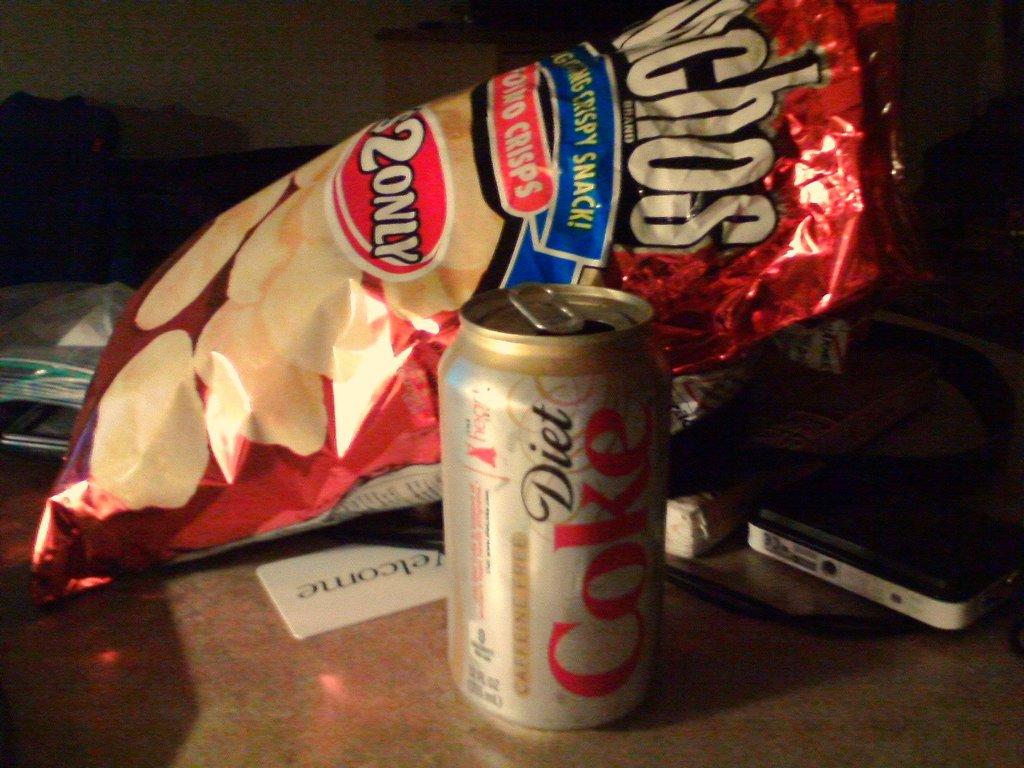How much did the chips cost?
Your answer should be compact. $2. 